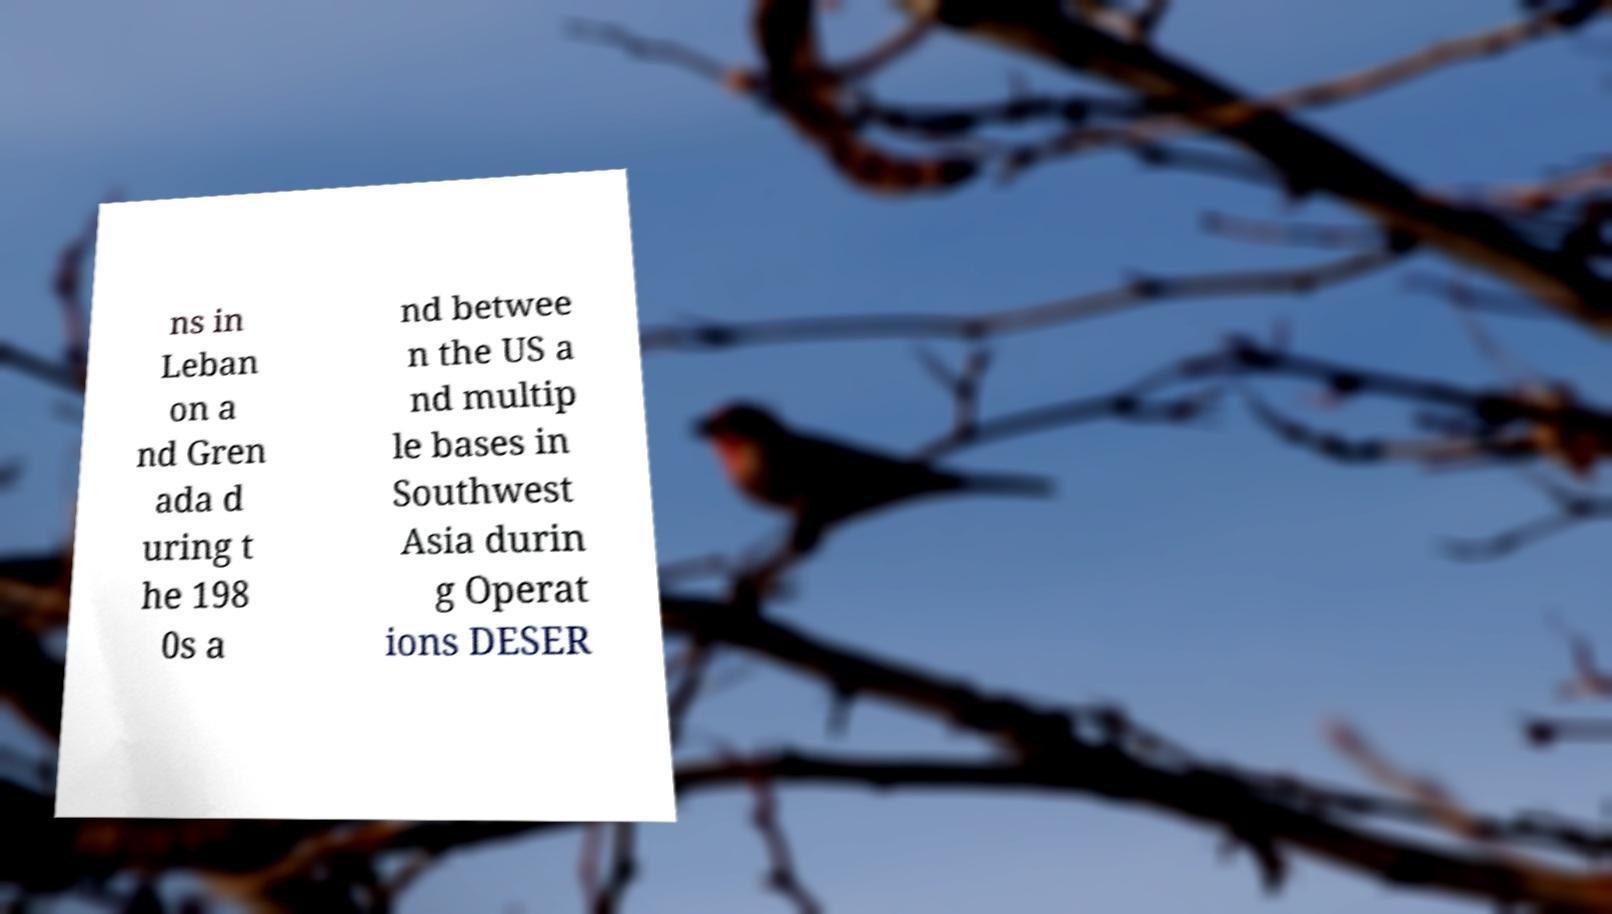Could you assist in decoding the text presented in this image and type it out clearly? ns in Leban on a nd Gren ada d uring t he 198 0s a nd betwee n the US a nd multip le bases in Southwest Asia durin g Operat ions DESER 